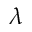Convert formula to latex. <formula><loc_0><loc_0><loc_500><loc_500>\lambda</formula> 